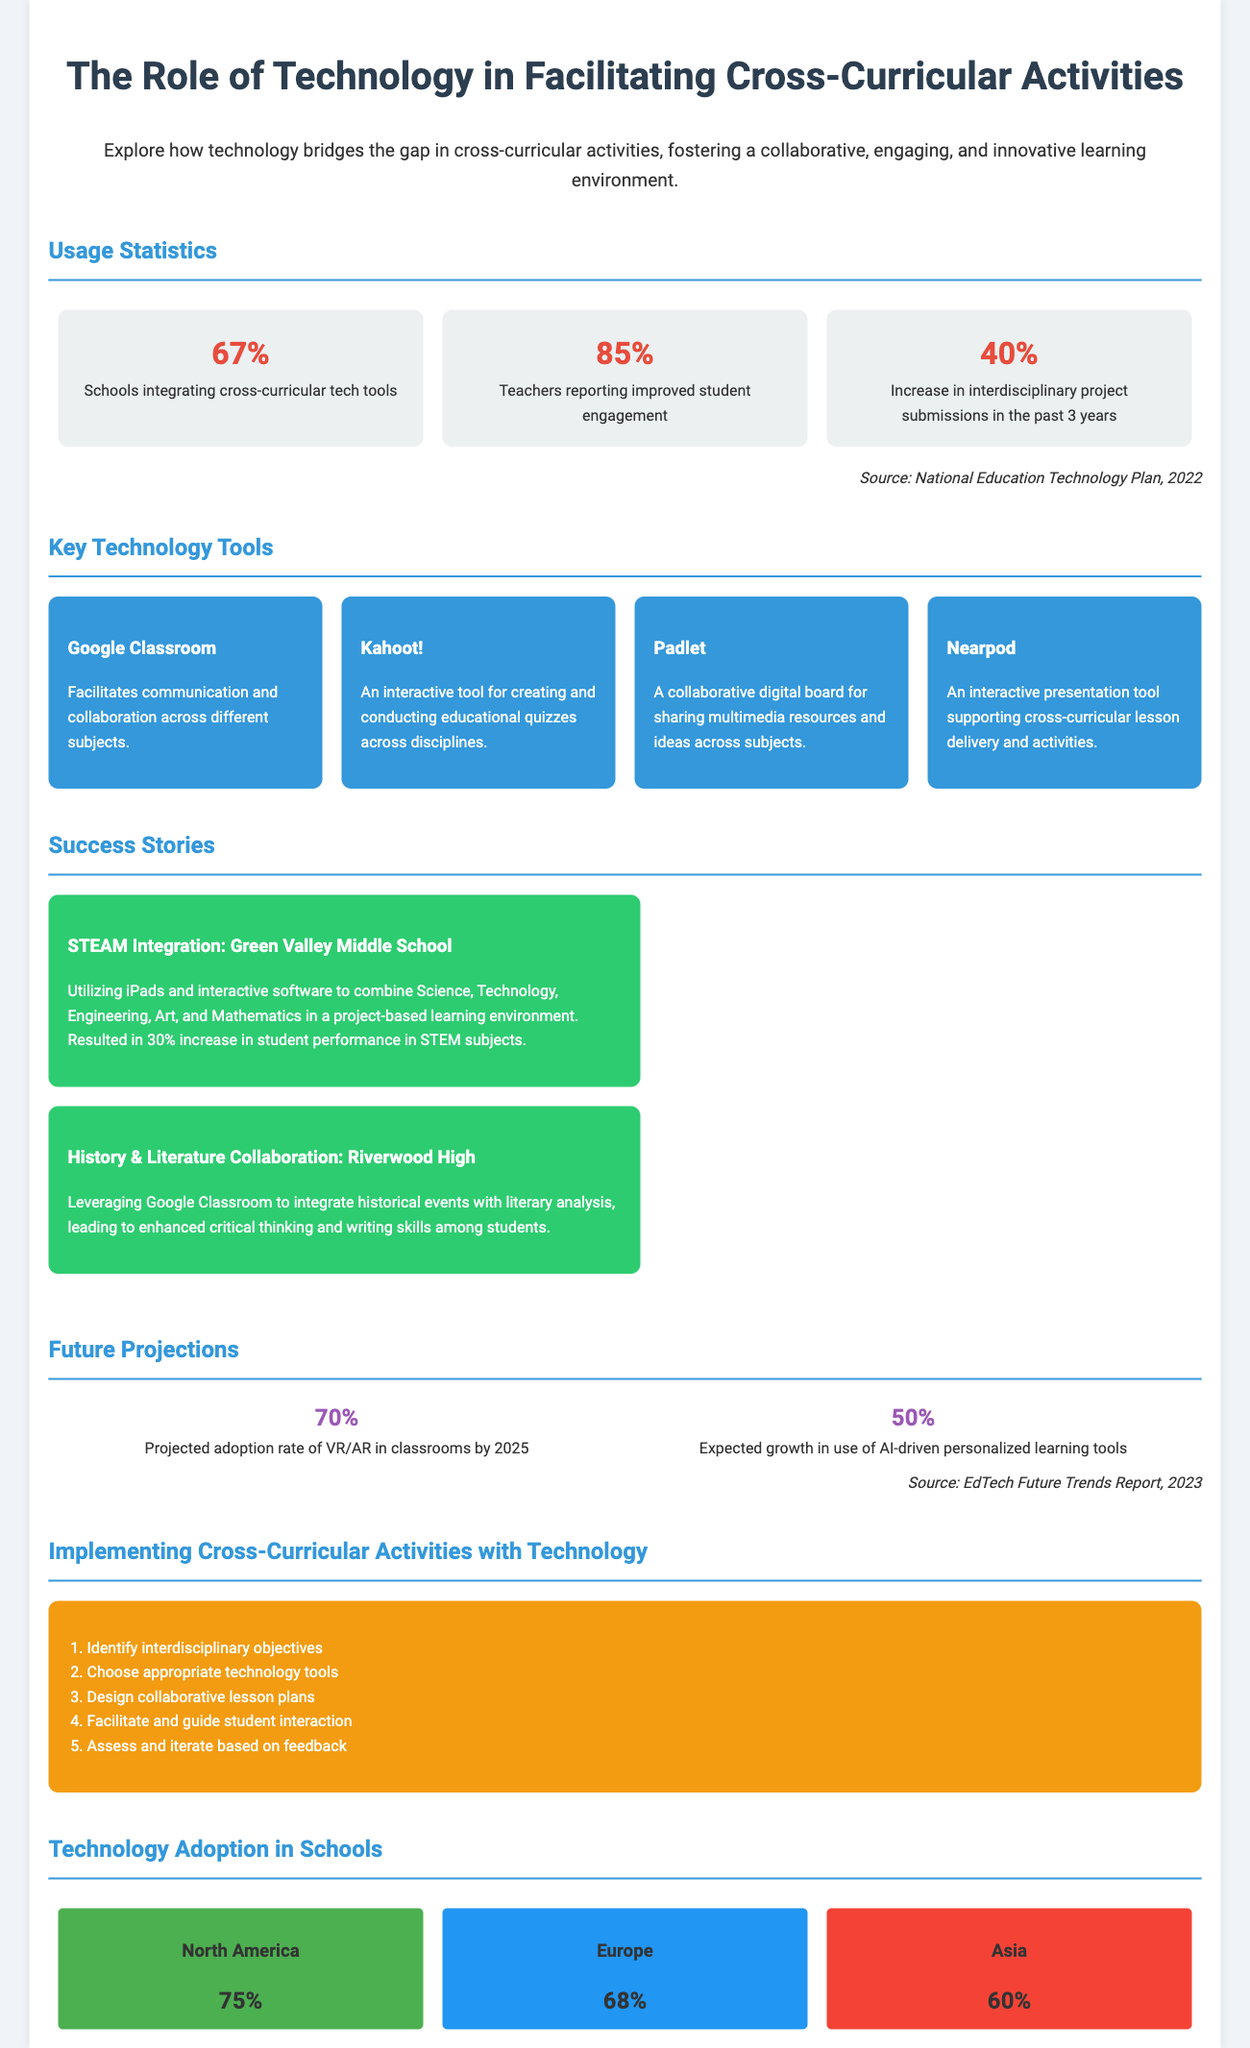what percentage of schools are integrating cross-curricular tech tools? The document states that 67% of schools are integrating these tools.
Answer: 67% what is the expected growth in the use of AI-driven personalized learning tools? The future projection mentions an expected growth of 50% in this area.
Answer: 50% which platform is used for creating educational quizzes? The infographic lists Kahoot! as the tool for creating educational quizzes.
Answer: Kahoot! what percentage of teachers report improved student engagement? According to the document, 85% of teachers report this improvement.
Answer: 85% which school utilized iPads for STEAM integration? The success story indicates that Green Valley Middle School utilized iPads.
Answer: Green Valley Middle School what is the projected adoption rate of VR/AR in classrooms by 2025? The document forecasts a projected adoption rate of 70% for VR/AR by that year.
Answer: 70% what are the first two steps in implementing cross-curricular activities with technology? The flowchart outlines identifying interdisciplinary objectives and choosing appropriate technology tools as the first two steps.
Answer: Identify interdisciplinary objectives, choose appropriate technology tools which region has the highest technology adoption rate in schools? The data map shows that North America has the highest adoption rate at 75%.
Answer: North America how many percent of interdisciplinary project submissions have increased in the past 3 years? The infographic mentions a 40% increase in these submissions.
Answer: 40% 